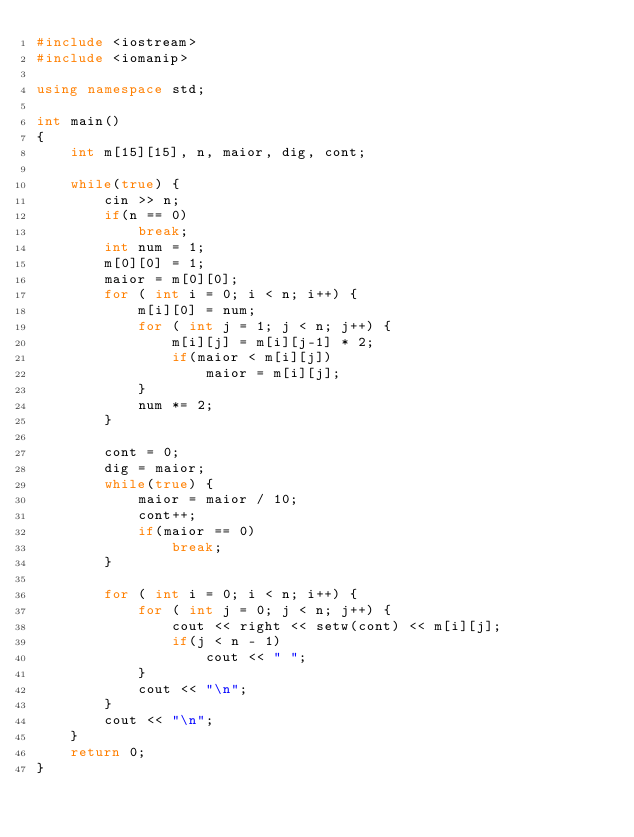<code> <loc_0><loc_0><loc_500><loc_500><_C++_>#include <iostream>
#include <iomanip>

using namespace std;

int main()
{
    int m[15][15], n, maior, dig, cont;

    while(true) {
        cin >> n;
        if(n == 0)
            break;
        int num = 1;
        m[0][0] = 1;
        maior = m[0][0];
        for ( int i = 0; i < n; i++) {
            m[i][0] = num;
            for ( int j = 1; j < n; j++) {
                m[i][j] = m[i][j-1] * 2;
                if(maior < m[i][j])
                    maior = m[i][j];
            }
            num *= 2;
        }

        cont = 0;
        dig = maior;
        while(true) {
            maior = maior / 10;
            cont++;
            if(maior == 0)
                break;
        }

        for ( int i = 0; i < n; i++) {
            for ( int j = 0; j < n; j++) {
                cout << right << setw(cont) << m[i][j];
                if(j < n - 1)
                    cout << " ";
            }
            cout << "\n";
        }
        cout << "\n";
    }
    return 0;
}
</code> 